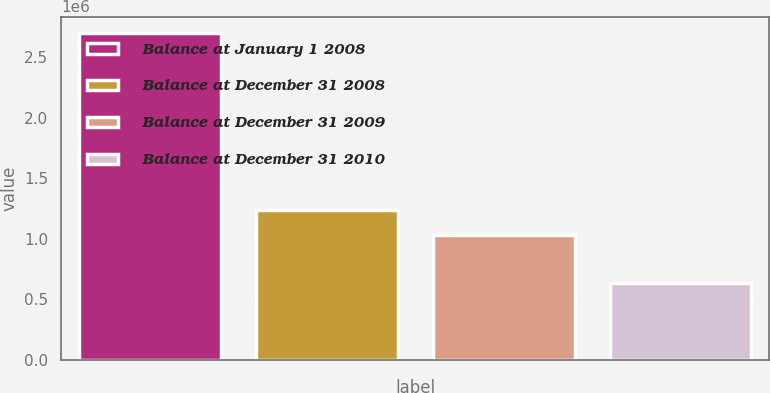Convert chart to OTSL. <chart><loc_0><loc_0><loc_500><loc_500><bar_chart><fcel>Balance at January 1 2008<fcel>Balance at December 31 2008<fcel>Balance at December 31 2009<fcel>Balance at December 31 2010<nl><fcel>2.69933e+06<fcel>1.24079e+06<fcel>1.03402e+06<fcel>631665<nl></chart> 